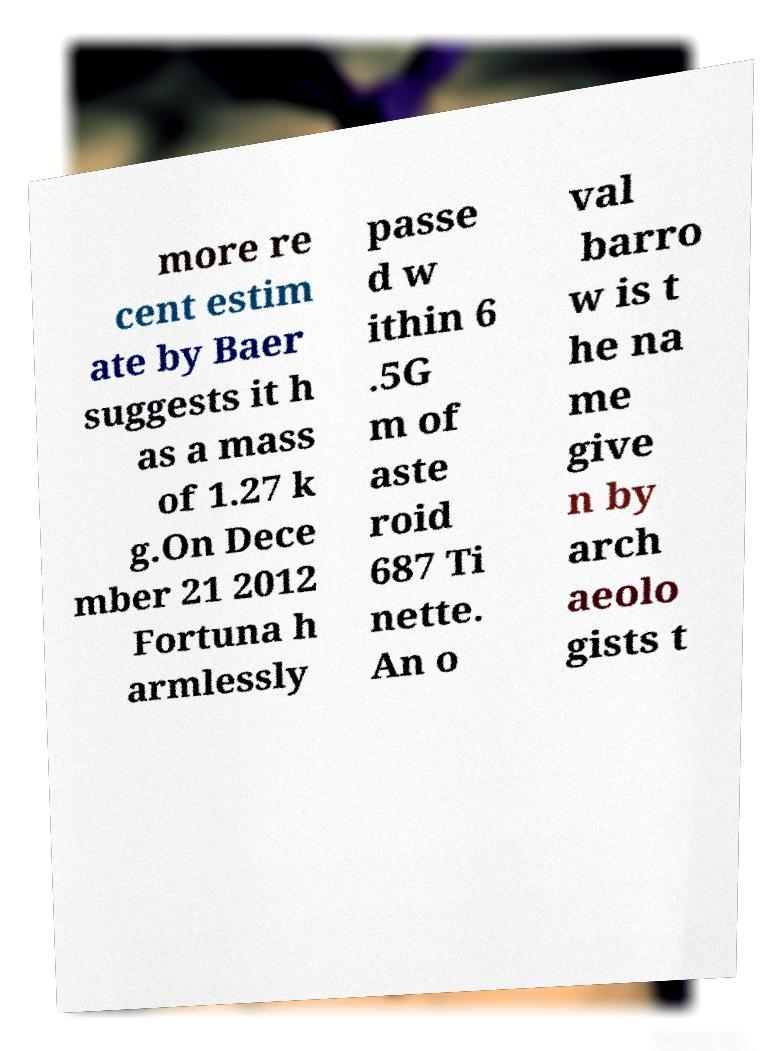Please read and relay the text visible in this image. What does it say? more re cent estim ate by Baer suggests it h as a mass of 1.27 k g.On Dece mber 21 2012 Fortuna h armlessly passe d w ithin 6 .5G m of aste roid 687 Ti nette. An o val barro w is t he na me give n by arch aeolo gists t 